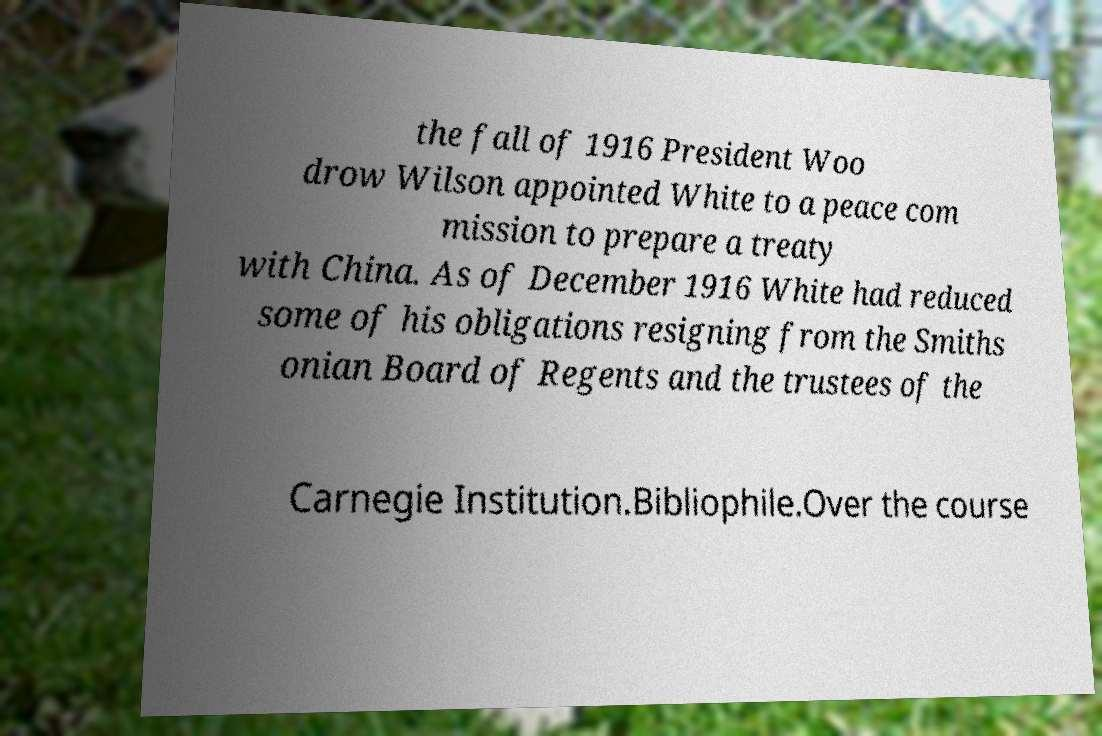What messages or text are displayed in this image? I need them in a readable, typed format. the fall of 1916 President Woo drow Wilson appointed White to a peace com mission to prepare a treaty with China. As of December 1916 White had reduced some of his obligations resigning from the Smiths onian Board of Regents and the trustees of the Carnegie Institution.Bibliophile.Over the course 